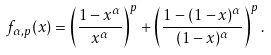<formula> <loc_0><loc_0><loc_500><loc_500>f _ { \alpha , p } ( x ) = \left ( \frac { 1 - x ^ { \alpha } } { x ^ { \alpha } } \right ) ^ { p } + \left ( \frac { 1 - ( 1 - x ) ^ { \alpha } } { ( 1 - x ) ^ { \alpha } } \right ) ^ { p } .</formula> 